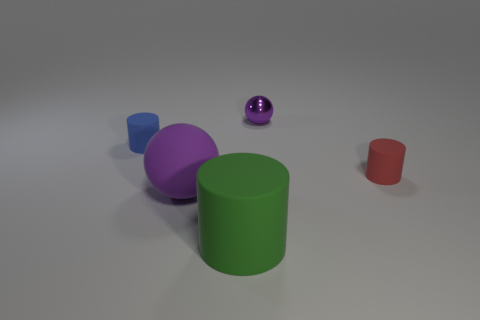There is a small blue matte object; how many big purple spheres are behind it?
Keep it short and to the point. 0. How many objects are in front of the purple rubber thing and to the left of the green matte cylinder?
Provide a succinct answer. 0. What shape is the big green object that is made of the same material as the blue thing?
Provide a short and direct response. Cylinder. There is a ball left of the tiny purple object; is it the same size as the cylinder behind the tiny red object?
Keep it short and to the point. No. The tiny cylinder on the left side of the purple rubber sphere is what color?
Keep it short and to the point. Blue. The cylinder behind the tiny matte thing to the right of the big purple rubber ball is made of what material?
Give a very brief answer. Rubber. What is the shape of the big purple matte thing?
Offer a terse response. Sphere. There is a small object that is the same shape as the big purple object; what is it made of?
Give a very brief answer. Metal. How many green rubber objects are the same size as the blue thing?
Your answer should be very brief. 0. There is a purple ball in front of the small red thing; is there a green matte cylinder that is on the left side of it?
Your answer should be very brief. No. 